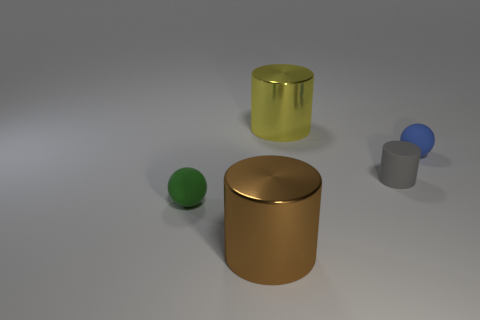What color is the cylinder that is both behind the brown thing and to the left of the gray rubber cylinder?
Your answer should be compact. Yellow. What size is the brown cylinder?
Give a very brief answer. Large. Is the color of the small ball in front of the small blue matte ball the same as the small cylinder?
Provide a short and direct response. No. Are there more brown shiny cylinders that are on the right side of the yellow shiny cylinder than tiny cylinders in front of the green rubber object?
Your answer should be compact. No. Is the number of big objects greater than the number of big yellow metal cubes?
Your response must be concise. Yes. There is a cylinder that is left of the matte cylinder and behind the green thing; how big is it?
Give a very brief answer. Large. The large brown object has what shape?
Your answer should be very brief. Cylinder. Are there any other things that are the same size as the green rubber ball?
Your answer should be compact. Yes. Are there more large metallic cylinders in front of the tiny matte cylinder than brown cylinders?
Offer a very short reply. No. There is a metal object behind the matte object that is to the left of the shiny thing that is to the left of the large yellow object; what is its shape?
Provide a succinct answer. Cylinder. 